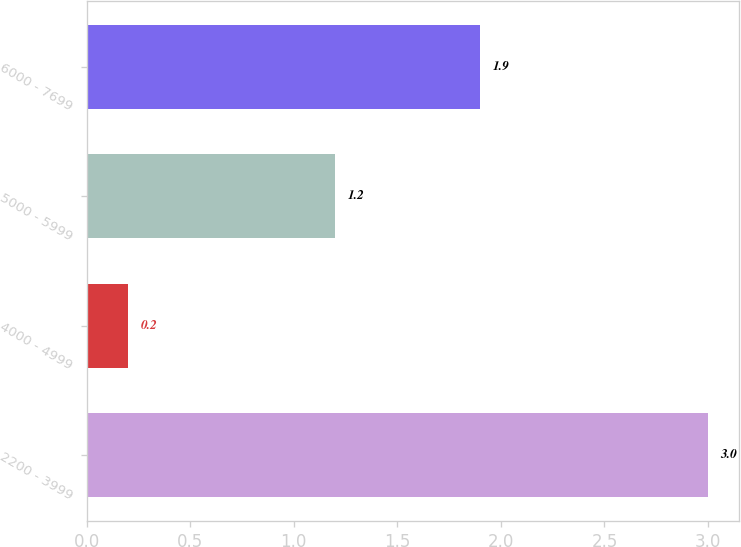Convert chart. <chart><loc_0><loc_0><loc_500><loc_500><bar_chart><fcel>2200 - 3999<fcel>4000 - 4999<fcel>5000 - 5999<fcel>6000 - 7699<nl><fcel>3<fcel>0.2<fcel>1.2<fcel>1.9<nl></chart> 